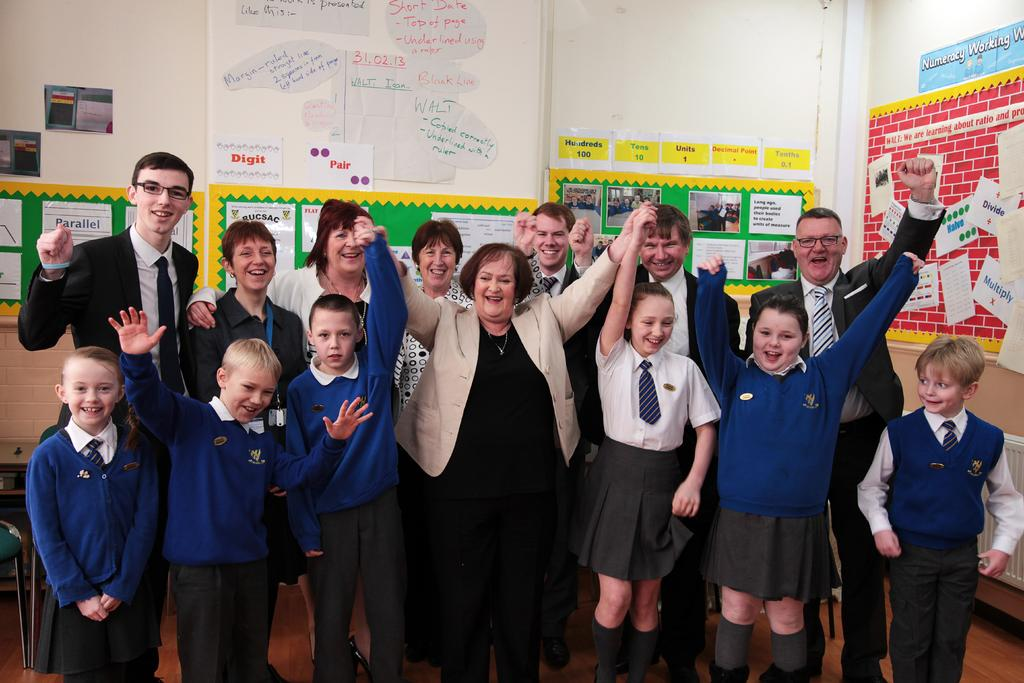What is happening in the image involving a group of people? There is a group of people in the image, and they are standing on the floor. What is the mood or expression of the people in the image? The people in the image are smiling. What can be seen in the background of the image? There are posters and a wall in the background of the image. Reasoning: Let's moods are described in the image? What is the location of the people in the image? The people are standing on the floor. What is the background of the image? The background of the image includes posters and a wall. Absurd Question/Answer: What type of pickle is being used as a prop in the image? There is no pickle present in the image. 